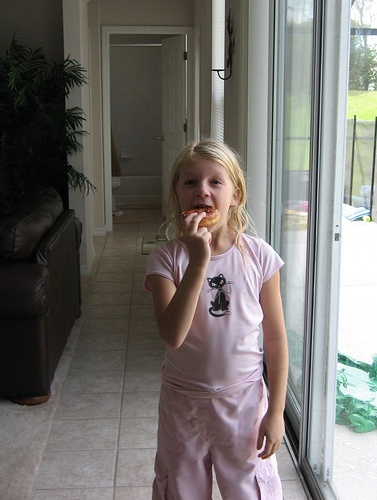Describe the objects in this image and their specific colors. I can see people in black, gray, darkgray, maroon, and lavender tones, couch in black and gray tones, potted plant in black and gray tones, cat in black, gray, and darkgray tones, and donut in black, maroon, and brown tones in this image. 